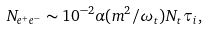<formula> <loc_0><loc_0><loc_500><loc_500>N _ { e ^ { + } e ^ { - } } \sim 1 0 ^ { - 2 } \alpha ( m ^ { 2 } / \omega _ { t } ) N _ { t } \tau _ { i } ,</formula> 